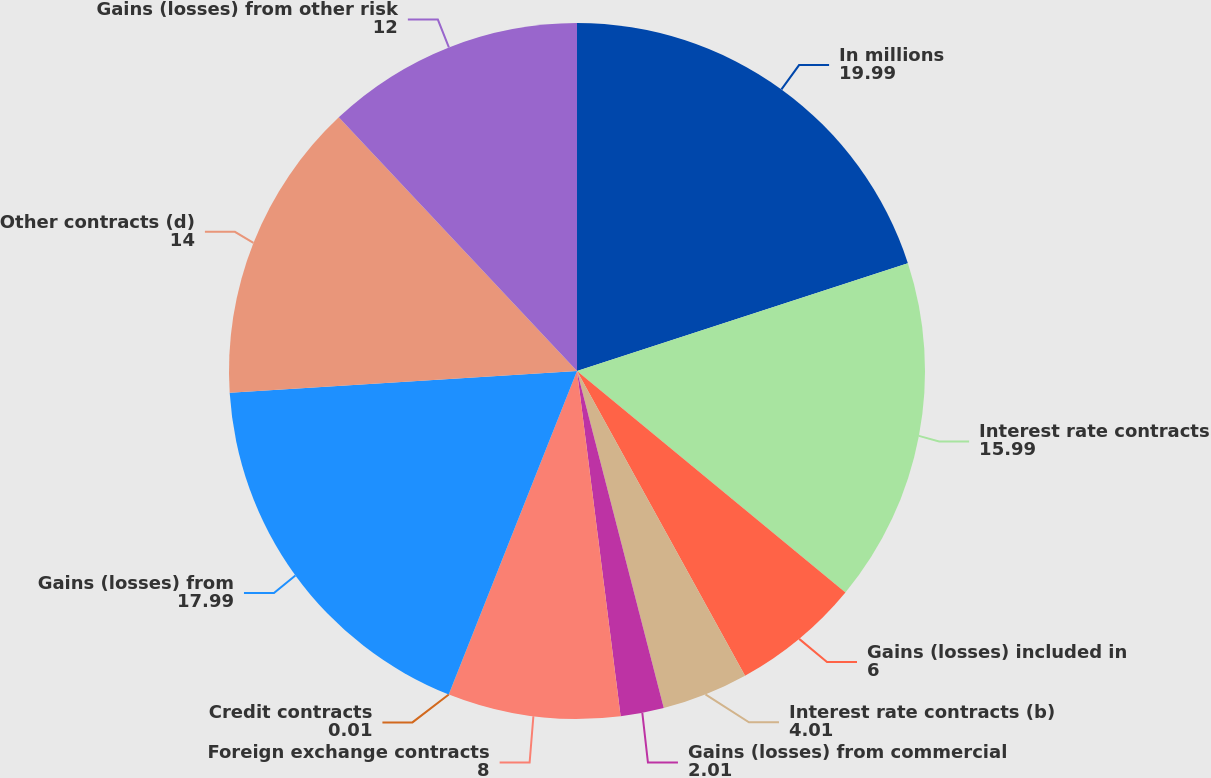<chart> <loc_0><loc_0><loc_500><loc_500><pie_chart><fcel>In millions<fcel>Interest rate contracts<fcel>Gains (losses) included in<fcel>Interest rate contracts (b)<fcel>Gains (losses) from commercial<fcel>Foreign exchange contracts<fcel>Credit contracts<fcel>Gains (losses) from<fcel>Other contracts (d)<fcel>Gains (losses) from other risk<nl><fcel>19.99%<fcel>15.99%<fcel>6.0%<fcel>4.01%<fcel>2.01%<fcel>8.0%<fcel>0.01%<fcel>17.99%<fcel>14.0%<fcel>12.0%<nl></chart> 